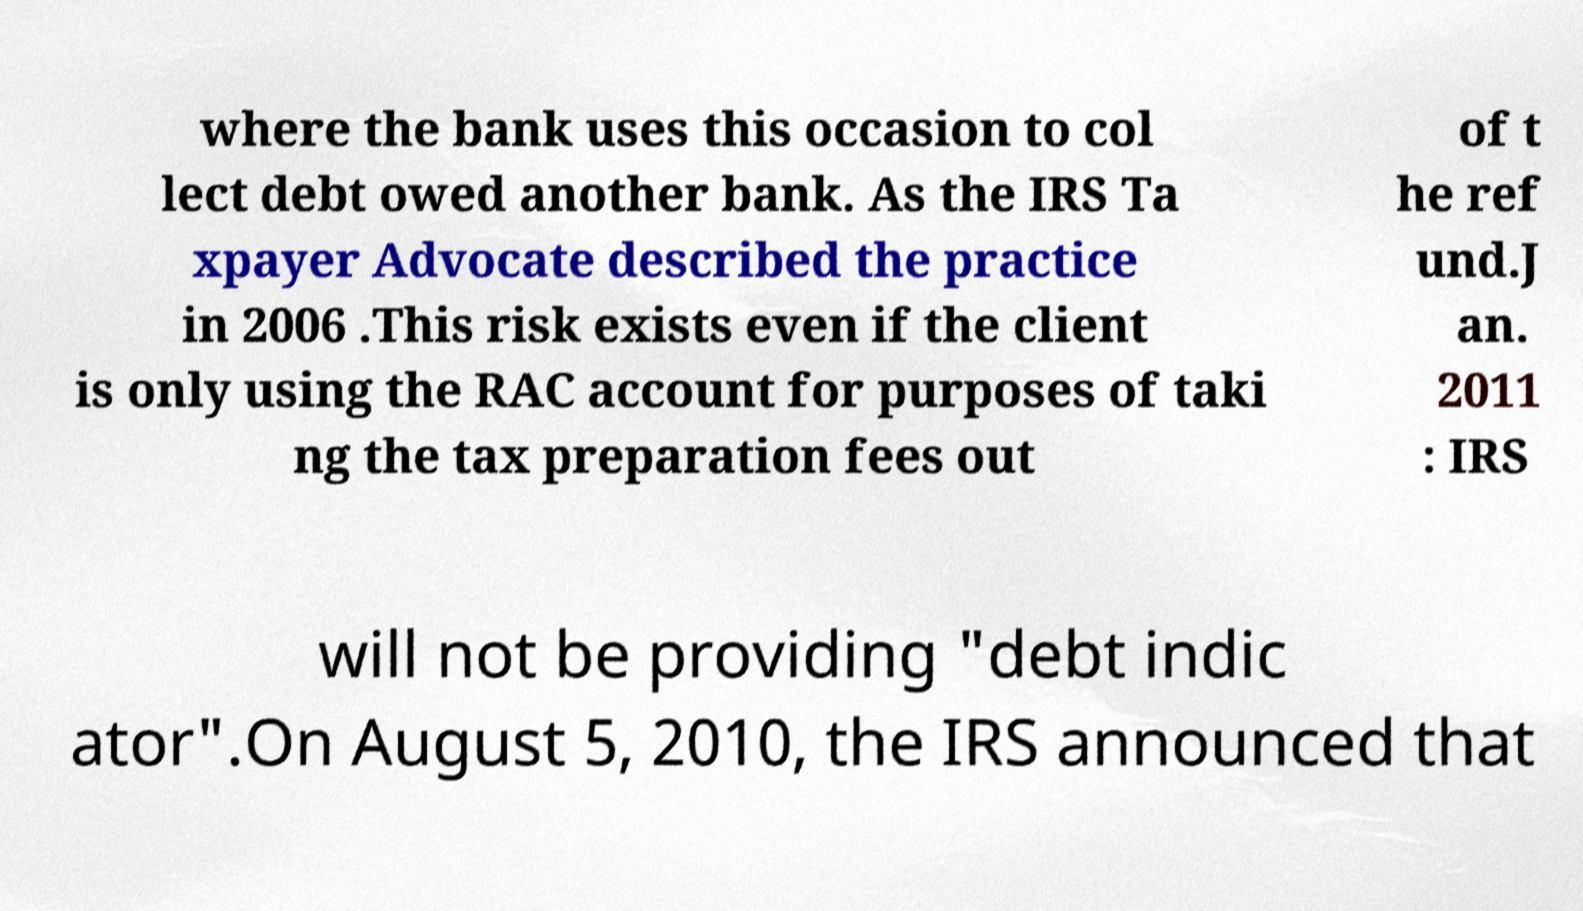Can you read and provide the text displayed in the image?This photo seems to have some interesting text. Can you extract and type it out for me? where the bank uses this occasion to col lect debt owed another bank. As the IRS Ta xpayer Advocate described the practice in 2006 .This risk exists even if the client is only using the RAC account for purposes of taki ng the tax preparation fees out of t he ref und.J an. 2011 : IRS will not be providing "debt indic ator".On August 5, 2010, the IRS announced that 